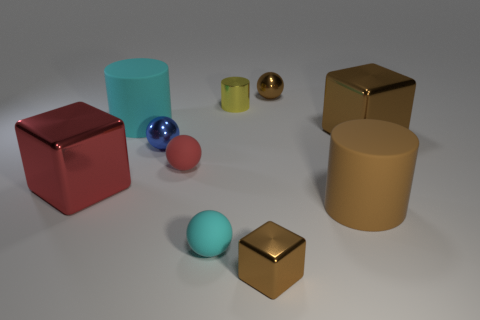There is a red sphere that is the same size as the blue metallic object; what is it made of? The red sphere appears to be made of a matte material, consistent with what you might expect from rubber or plastic, given its non-reflective surface and visual texture. 